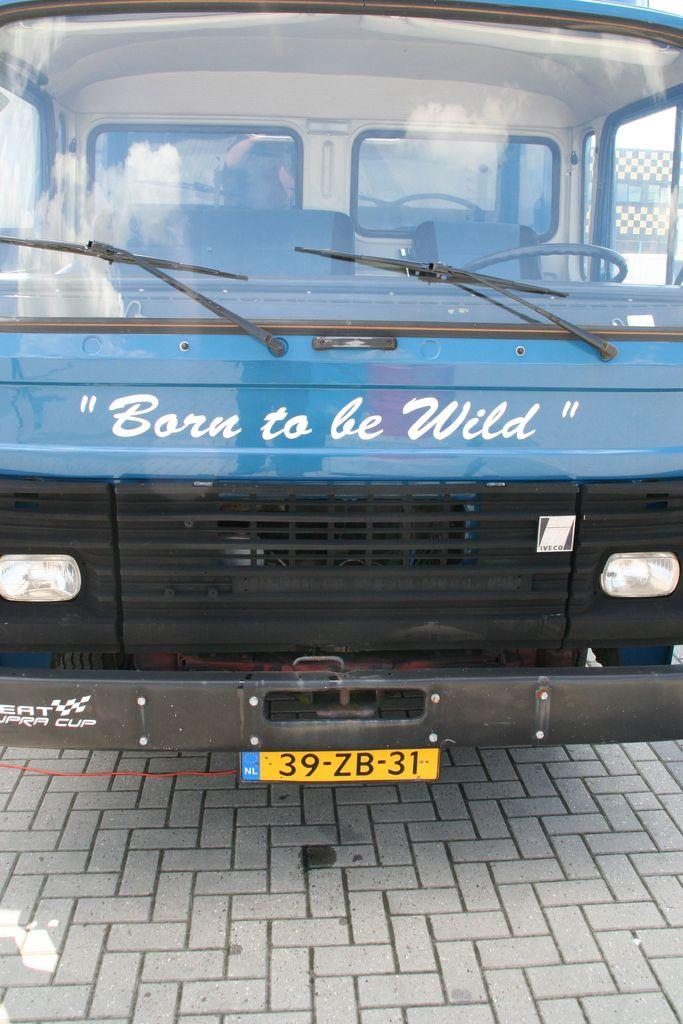<image>
Summarize the visual content of the image. The front of a blue truck with Born to be Wild on the front. 